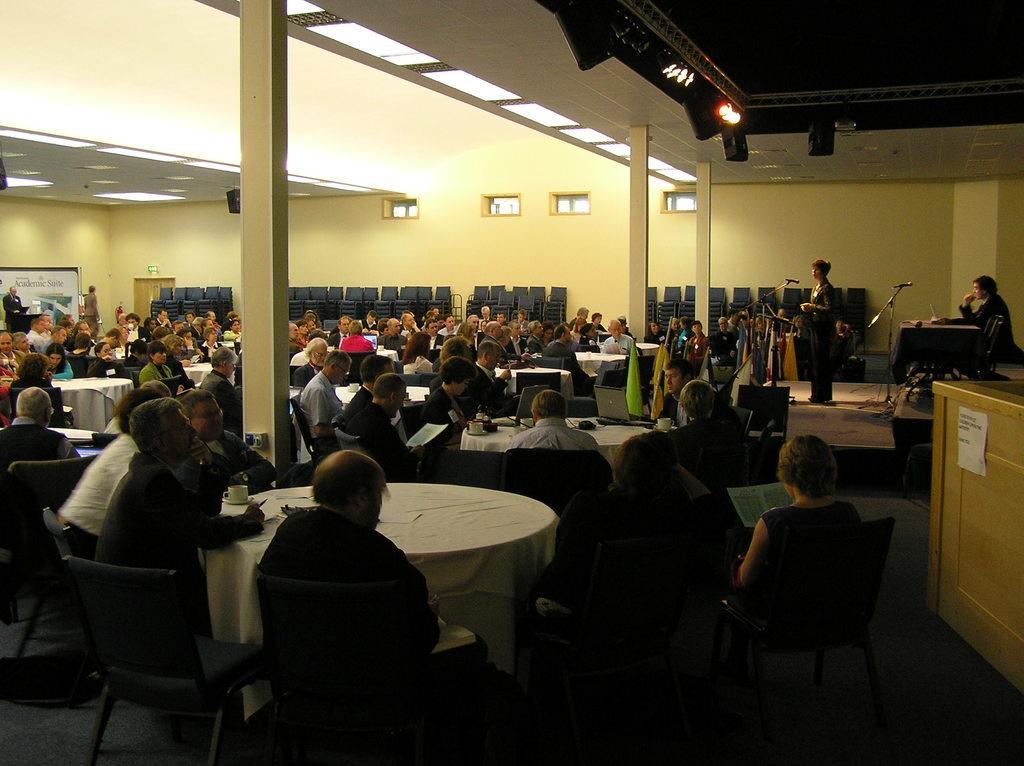How would you summarize this image in a sentence or two? There is a group of people. Some people are sitting on a chair and some people are standing on a dais. There is a table. There is a laptop. coffee cup on a table. We can see the background there is a pillar ,wall. 